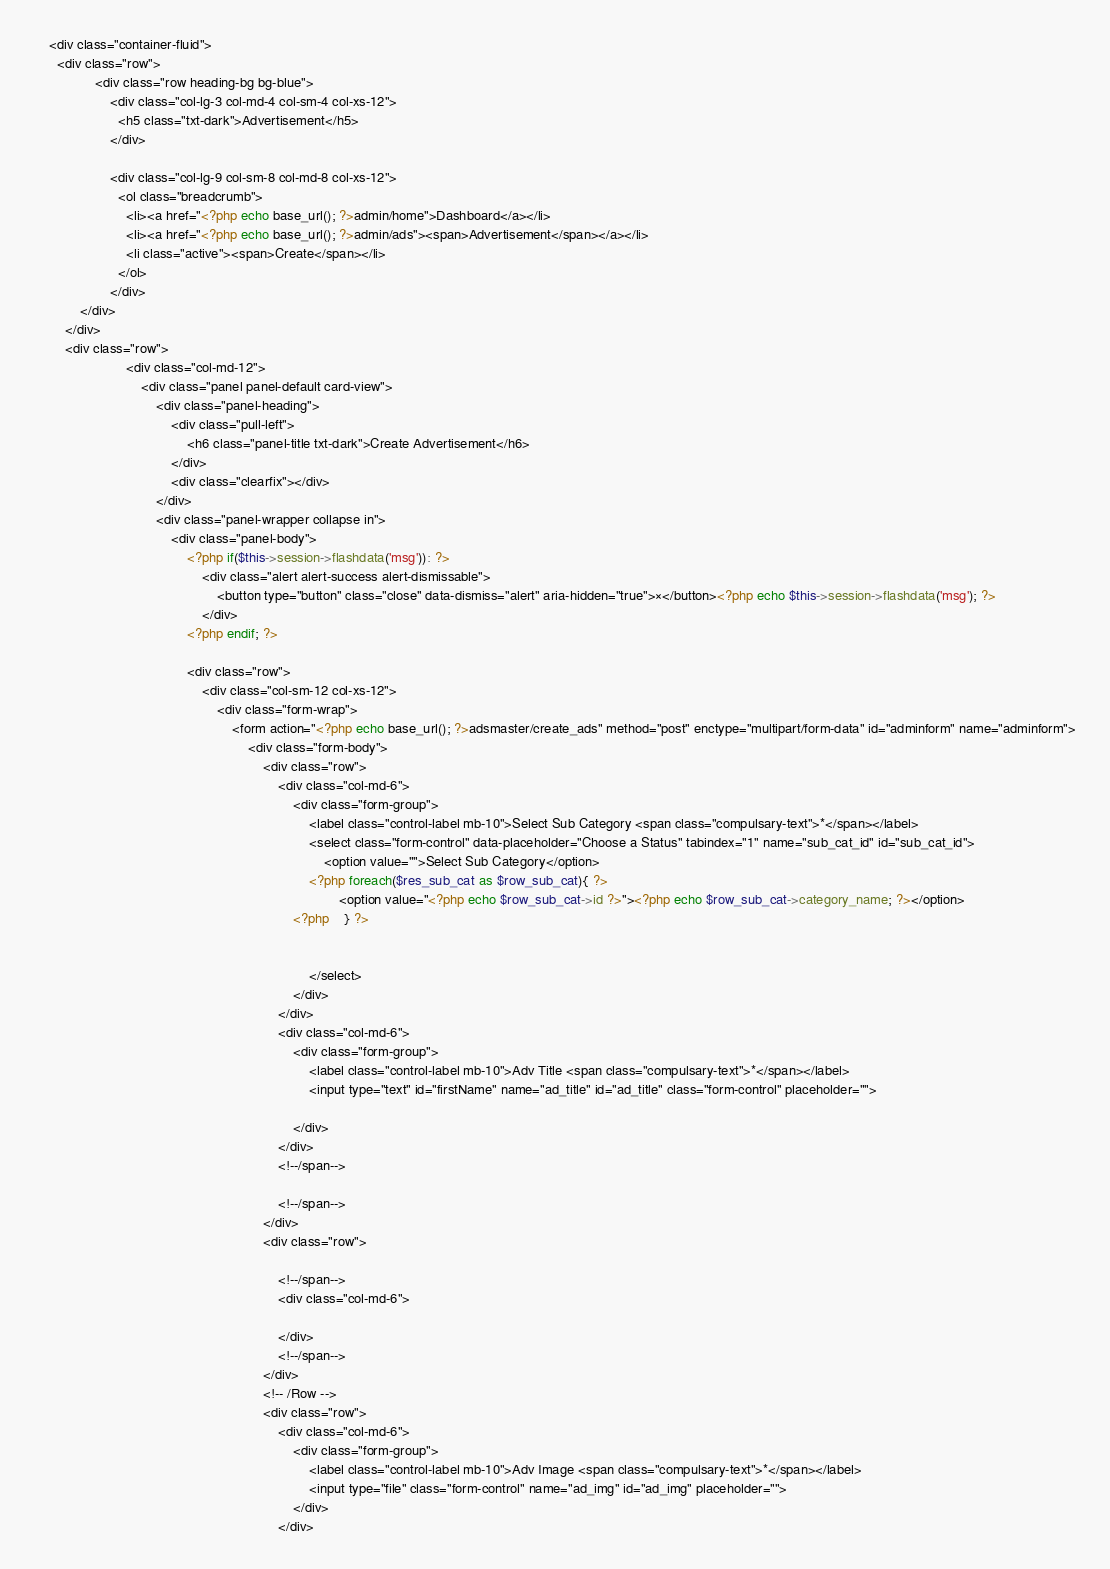<code> <loc_0><loc_0><loc_500><loc_500><_PHP_>	<div class="container-fluid">
      <div class="row">
				<div class="row heading-bg bg-blue">
					<div class="col-lg-3 col-md-4 col-sm-4 col-xs-12">
					  <h5 class="txt-dark">Advertisement</h5>
					</div>

					<div class="col-lg-9 col-sm-8 col-md-8 col-xs-12">
					  <ol class="breadcrumb">
						<li><a href="<?php echo base_url(); ?>admin/home">Dashboard</a></li>
						<li><a href="<?php echo base_url(); ?>admin/ads"><span>Advertisement</span></a></li>
						<li class="active"><span>Create</span></li>
					  </ol>
					</div>
			</div>
		</div>
		<div class="row">
						<div class="col-md-12">
							<div class="panel panel-default card-view">
								<div class="panel-heading">
									<div class="pull-left">
										<h6 class="panel-title txt-dark">Create Advertisement</h6>
									</div>
									<div class="clearfix"></div>
								</div>
								<div class="panel-wrapper collapse in">
									<div class="panel-body">
										<?php if($this->session->flashdata('msg')): ?>
											<div class="alert alert-success alert-dismissable">
												<button type="button" class="close" data-dismiss="alert" aria-hidden="true">×</button><?php echo $this->session->flashdata('msg'); ?>
											</div>
										<?php endif; ?>

										<div class="row">
											<div class="col-sm-12 col-xs-12">
												<div class="form-wrap">
													<form action="<?php echo base_url(); ?>adsmaster/create_ads" method="post" enctype="multipart/form-data" id="adminform" name="adminform">
														<div class="form-body">
															<div class="row">
																<div class="col-md-6">
																	<div class="form-group">
																		<label class="control-label mb-10">Select Sub Category <span class="compulsary-text">*</span></label>
																		<select class="form-control" data-placeholder="Choose a Status" tabindex="1" name="sub_cat_id" id="sub_cat_id">
																			<option value="">Select Sub Category</option>
																		<?php foreach($res_sub_cat as $row_sub_cat){ ?>
																				<option value="<?php echo $row_sub_cat->id ?>"><?php echo $row_sub_cat->category_name; ?></option>
																	<?php 	} ?>


																		</select>
																	</div>
																</div>
																<div class="col-md-6">
																	<div class="form-group">
																		<label class="control-label mb-10">Adv Title <span class="compulsary-text">*</span></label>
																		<input type="text" id="firstName" name="ad_title" id="ad_title" class="form-control" placeholder="">

																	</div>
																</div>
																<!--/span-->

																<!--/span-->
															</div>
															<div class="row">
																
																<!--/span-->
																<div class="col-md-6">

																</div>
																<!--/span-->
															</div>
															<!-- /Row -->
															<div class="row">
																<div class="col-md-6">
																	<div class="form-group">
																		<label class="control-label mb-10">Adv Image <span class="compulsary-text">*</span></label>
																		<input type="file" class="form-control" name="ad_img" id="ad_img" placeholder="">
																	</div>
																</div></code> 